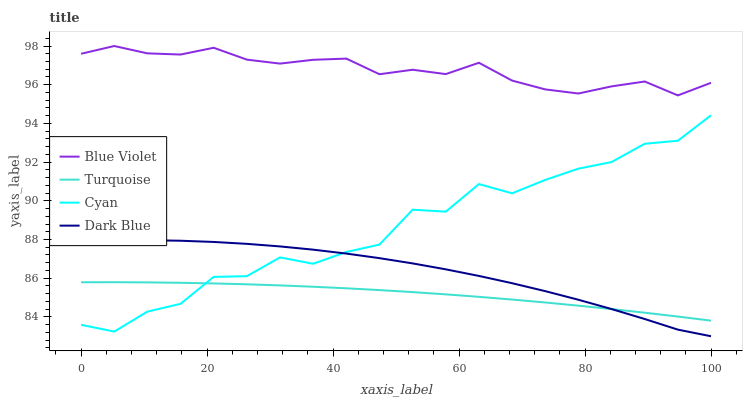Does Turquoise have the minimum area under the curve?
Answer yes or no. Yes. Does Blue Violet have the maximum area under the curve?
Answer yes or no. Yes. Does Blue Violet have the minimum area under the curve?
Answer yes or no. No. Does Turquoise have the maximum area under the curve?
Answer yes or no. No. Is Turquoise the smoothest?
Answer yes or no. Yes. Is Cyan the roughest?
Answer yes or no. Yes. Is Blue Violet the smoothest?
Answer yes or no. No. Is Blue Violet the roughest?
Answer yes or no. No. Does Turquoise have the lowest value?
Answer yes or no. No. Does Blue Violet have the highest value?
Answer yes or no. Yes. Does Turquoise have the highest value?
Answer yes or no. No. Is Dark Blue less than Blue Violet?
Answer yes or no. Yes. Is Blue Violet greater than Turquoise?
Answer yes or no. Yes. Does Dark Blue intersect Turquoise?
Answer yes or no. Yes. Is Dark Blue less than Turquoise?
Answer yes or no. No. Is Dark Blue greater than Turquoise?
Answer yes or no. No. Does Dark Blue intersect Blue Violet?
Answer yes or no. No. 